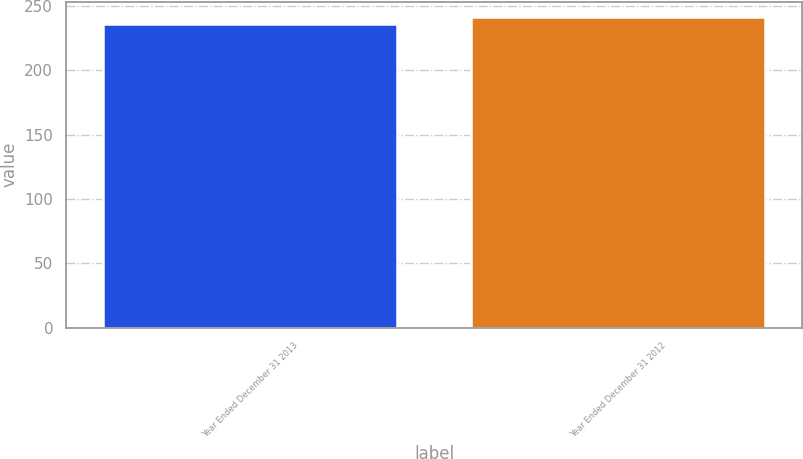Convert chart to OTSL. <chart><loc_0><loc_0><loc_500><loc_500><bar_chart><fcel>Year Ended December 31 2013<fcel>Year Ended December 31 2012<nl><fcel>236<fcel>241<nl></chart> 